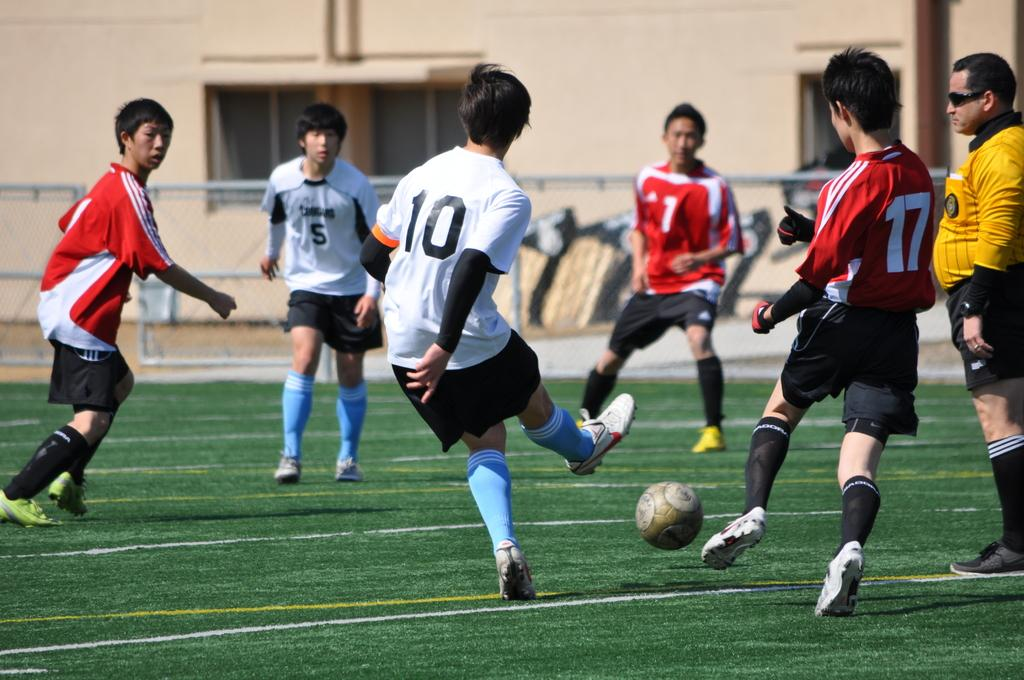What activity are the people in the image engaged in? The people in the image are playing football. What type of structure can be seen in the background of the image? There is a wall with windows in the image. What type of barrier is visible in the image? There is fencing visible in the image. How many eyes does the football have in the image? The football does not have eyes; it is an inanimate object. 